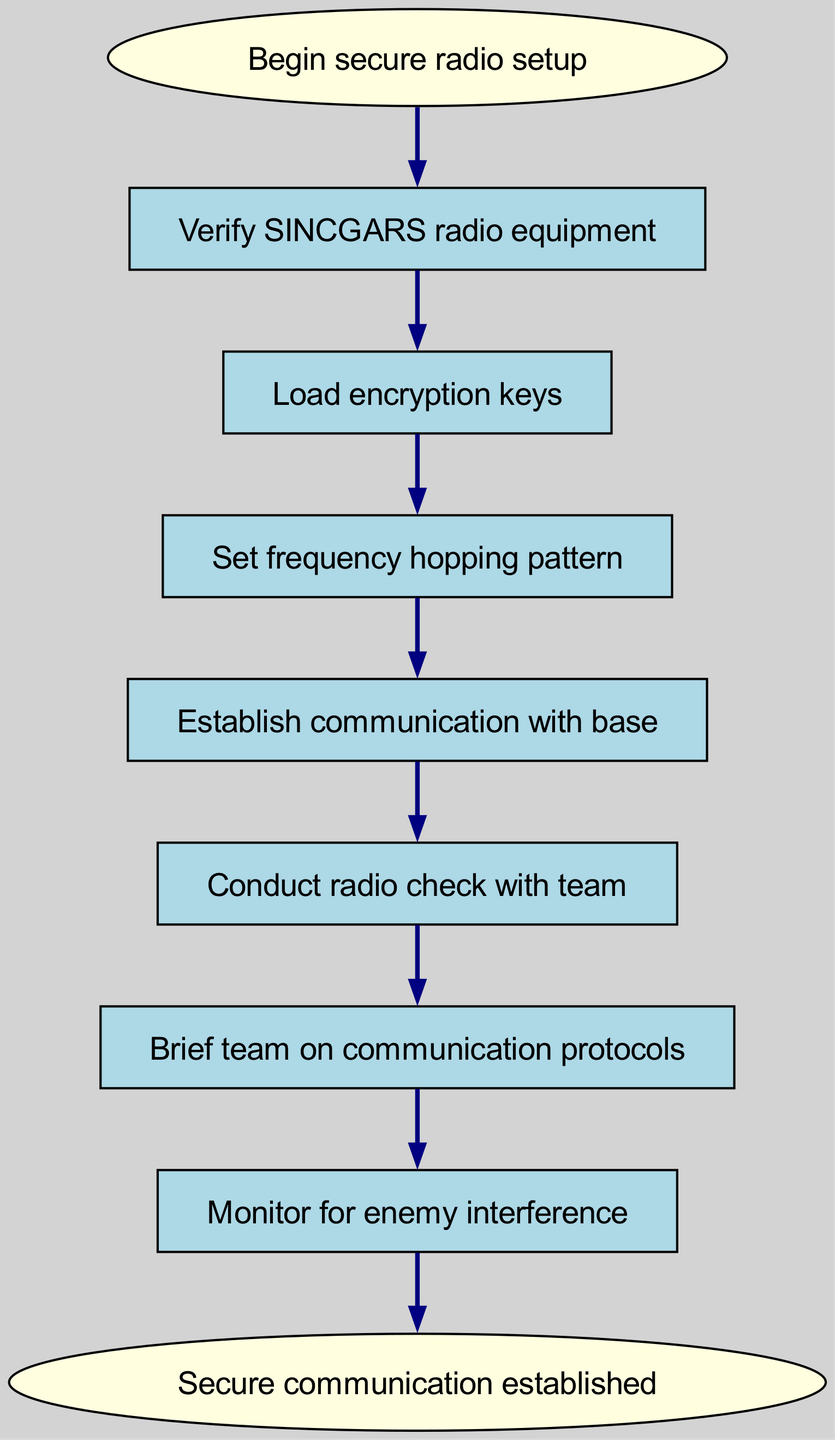What is the first step in the secure radio setup? The first step is represented by the "start" node, which indicates the beginning of the process for secure radio setup. Following this node, the first instruction is to verify the SINCGARS radio equipment.
Answer: Verify SINCGARS radio equipment How many total nodes are there in the diagram? Counting each node in the diagram, including the start and end nodes, we see a total of eight nodes: one for the start, six process steps, and one for the end.
Answer: Eight Which step follows the "Set frequency hopping pattern"? The connections in the diagram show that directly after "Set frequency hopping pattern," the next step is to "Establish communication with base."
Answer: Establish communication with base What is the last action before securing communication? The flow chart indicates that the action just before securing communication is to "Monitor for enemy interference," which is the final processing step before the end node is reached.
Answer: Monitor for enemy interference What are the two final steps in the communication process? Analyzing the last few connections, we see that the flow from the last action leads to the final communication confirmation. The last two steps are "Brief team on communication protocols" followed by "Monitor for enemy interference."
Answer: Brief team on communication protocols, Monitor for enemy interference Why is it essential to "Conduct radio check with team" after establishing communication with the base? Conducting a radio check ensures that the established communication is working correctly and that all team members can receive and transmit messages effectively, which is vital for secure operations. This step is crucial for confirming reliability before proceeding further.
Answer: To confirm reliability How does enemy interference monitoring fit into the overall communication security process? Monitoring for enemy interference acts as a critical step after all protocols and communication setups have been established, helping to ensure that the secure communication remains protected against any potential enemy actions. This proactive measure is designed to safeguard the reliability of communications in hostile territory.
Answer: Protects communication reliability What is the final outcome of following this flow chart? The ultimate outcome is indicated in the end node as "Secure communication established," which signifies that all required steps have been successfully completed to ensure secure and reliable radio communication.
Answer: Secure communication established 